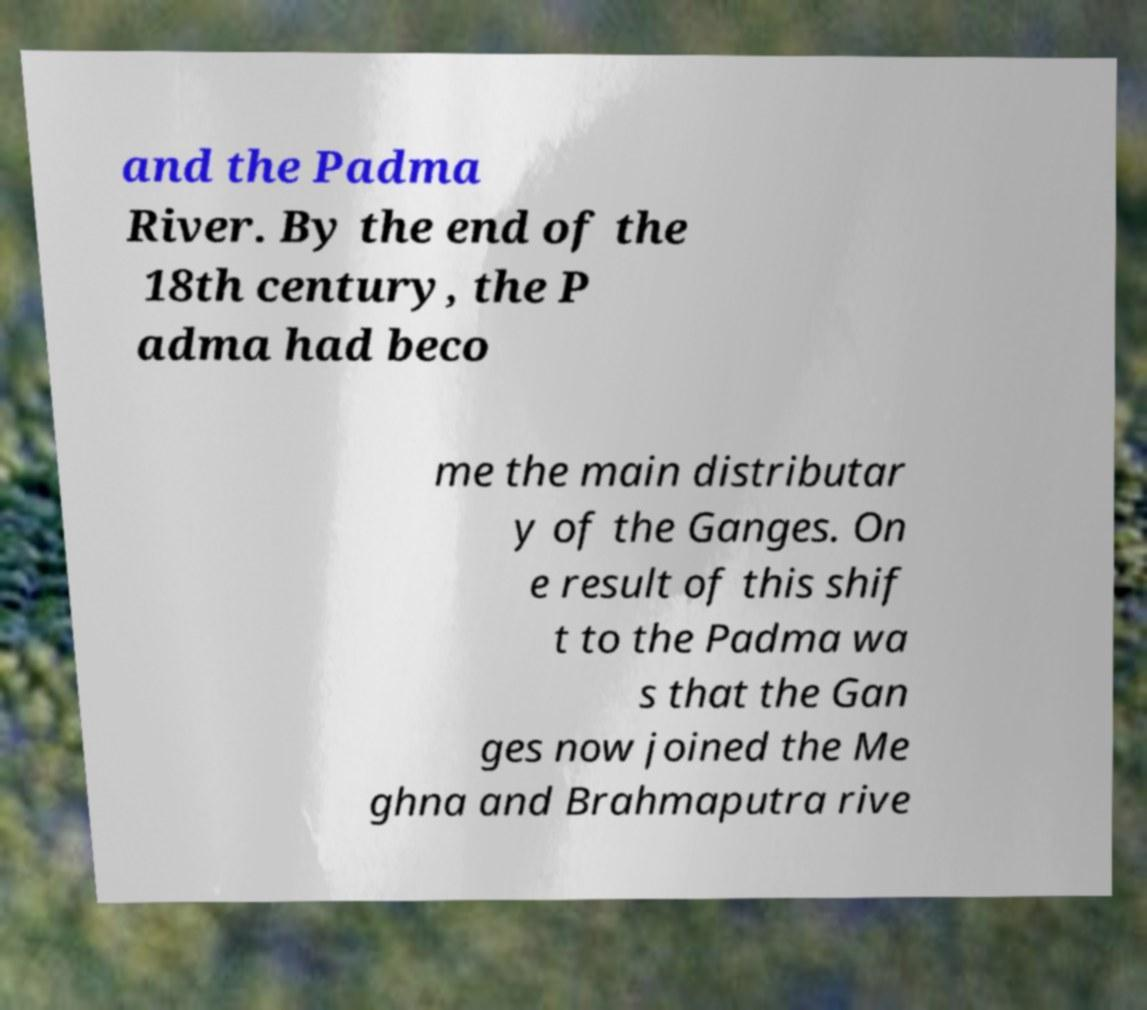For documentation purposes, I need the text within this image transcribed. Could you provide that? and the Padma River. By the end of the 18th century, the P adma had beco me the main distributar y of the Ganges. On e result of this shif t to the Padma wa s that the Gan ges now joined the Me ghna and Brahmaputra rive 